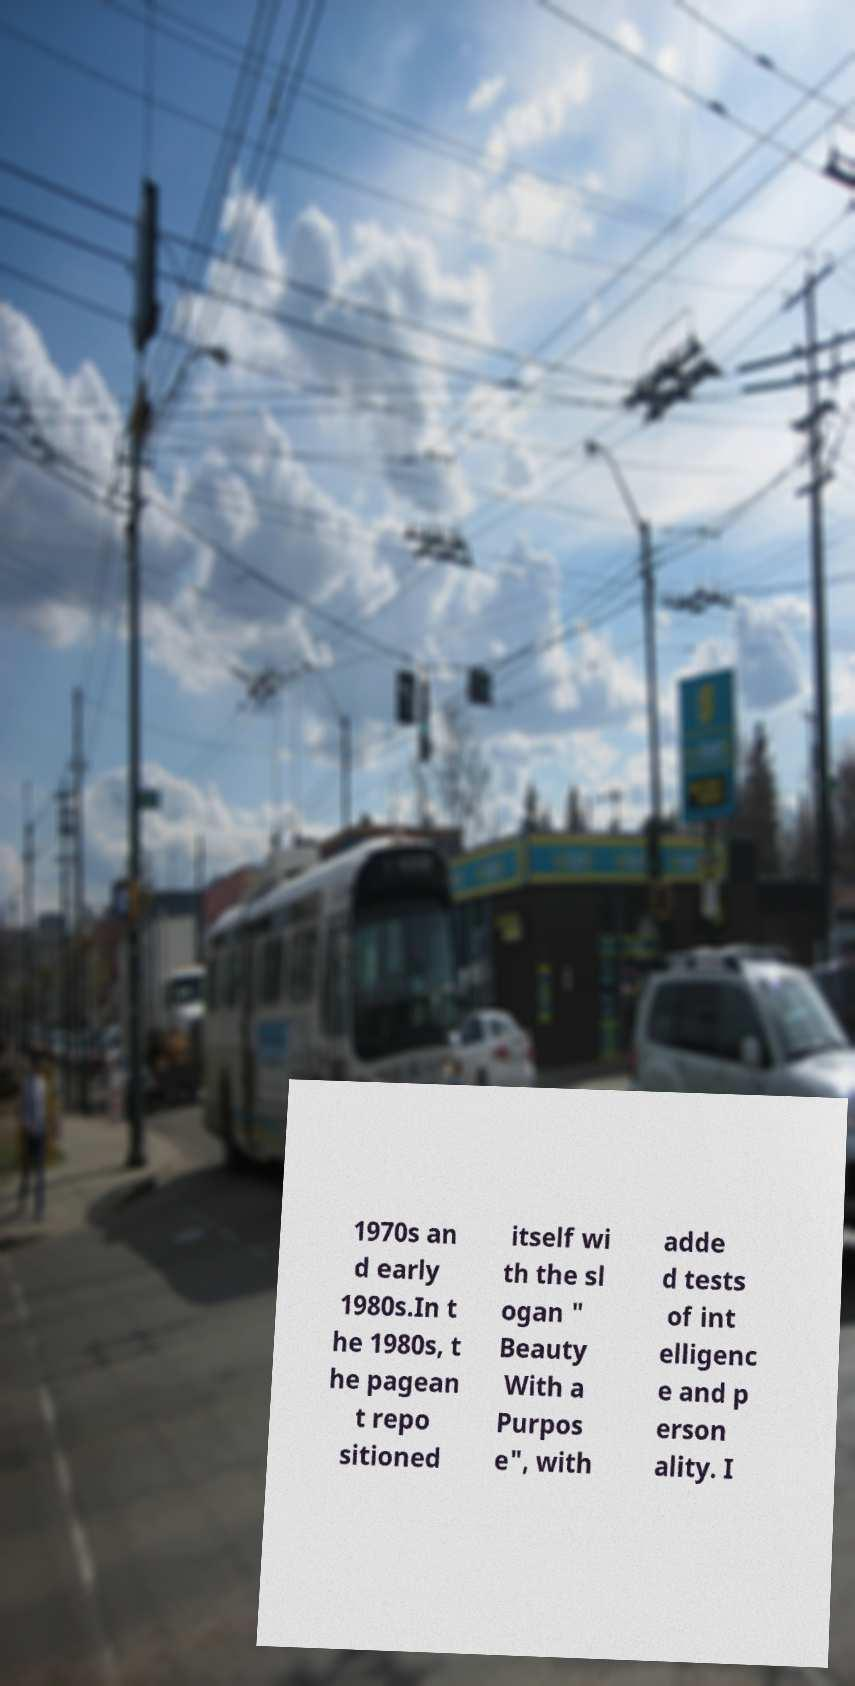Can you read and provide the text displayed in the image?This photo seems to have some interesting text. Can you extract and type it out for me? 1970s an d early 1980s.In t he 1980s, t he pagean t repo sitioned itself wi th the sl ogan " Beauty With a Purpos e", with adde d tests of int elligenc e and p erson ality. I 